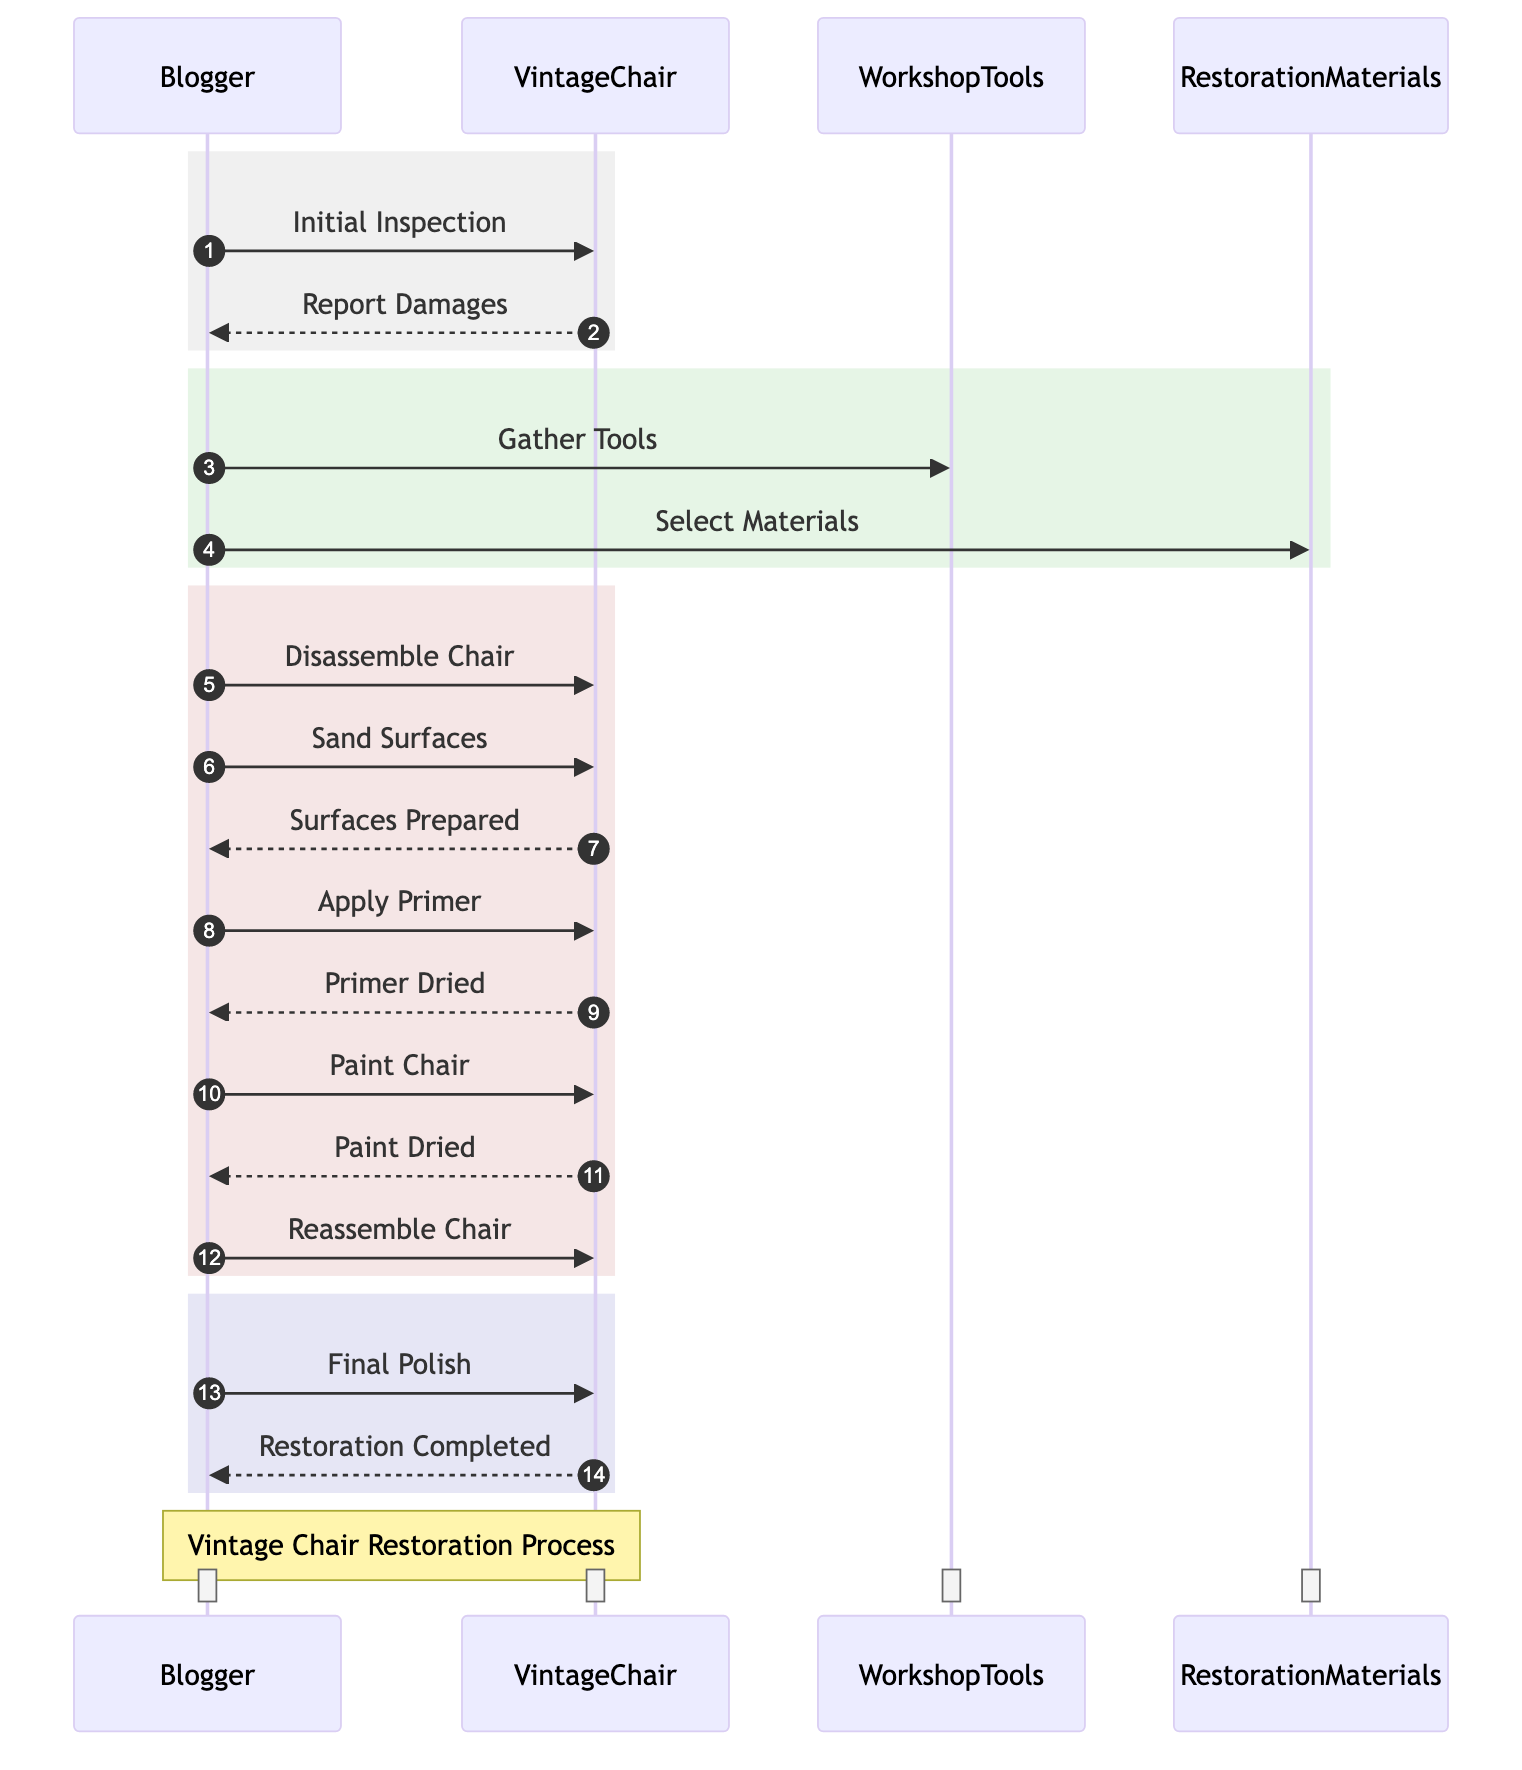What is the first action taken by the Blogger? The diagram shows that the first action the Blogger takes is the "Initial Inspection" of the Vintage Chair. This is indicated by the first message from the Blogger to the Vintage Chair.
Answer: Initial Inspection How many participants are involved in the process? The diagram lists four participants: the Blogger, Vintage Chair, Workshop Tools, and Restoration Materials. By counting these, we find there are a total of four participants involved in the process.
Answer: Four What is the last action performed by the Blogger? The final action in the sequence diagram where the Blogger interacts with the Vintage Chair is "Final Polish". This is seen at the end of the series of messages directed to the Vintage Chair.
Answer: Final Polish What does the Vintage Chair report after the surfaces are sanded? After the Blogger sands the surfaces of the Vintage Chair, the Vintage Chair responds with "Surfaces Prepared". This message indicates that the preparation process is complete.
Answer: Surfaces Prepared What materials does the Blogger interact with during the restoration? In the restoration process, the Blogger interacts with "Workshop Tools" and "Restoration Materials" based on the messages directed to these objects. Both of these play a crucial role in the restoration.
Answer: Workshop Tools, Restoration Materials Which action follows immediately after "Apply Primer"? The sequence indicates that "Primer Dried" is received from the Vintage Chair immediately after the Blogger applies the primer. This shows the progression of actions within the diagram.
Answer: Primer Dried What does the Vintage Chair indicate after the Blogger paints it? After the Blogger paints the Vintage Chair, it indicates "Paint Dried". This message is a confirmation of the state of the paint after application.
Answer: Paint Dried How many distinct steps are there in the process? By reviewing all the actions depicted in the diagram, including each of the interactions between the Blogger and the Vintage Chair, there are a total of 14 distinct steps in the process.
Answer: Fourteen What type of diagram is this? This is a sequence diagram, which visually represents the interactions and flow of messages between different participants in order of time. It shows the sequential order of the restoration process.
Answer: Sequence Diagram 